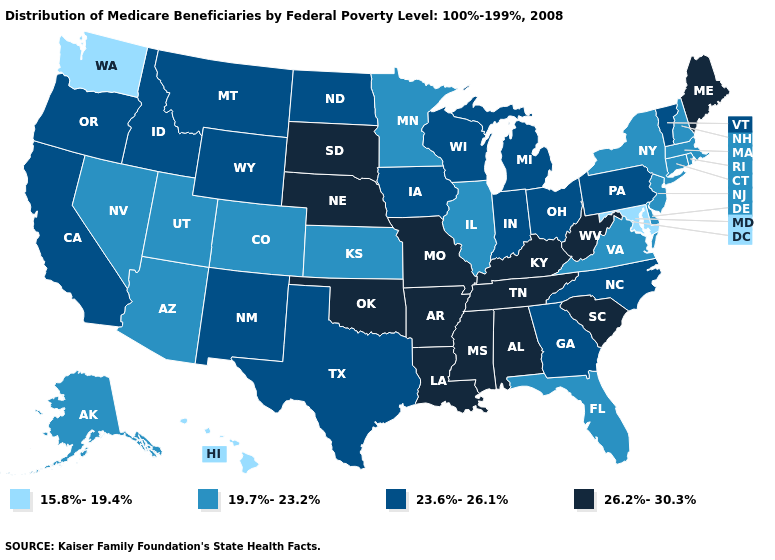Is the legend a continuous bar?
Short answer required. No. Name the states that have a value in the range 26.2%-30.3%?
Write a very short answer. Alabama, Arkansas, Kentucky, Louisiana, Maine, Mississippi, Missouri, Nebraska, Oklahoma, South Carolina, South Dakota, Tennessee, West Virginia. What is the value of Michigan?
Concise answer only. 23.6%-26.1%. Does Mississippi have a higher value than New Hampshire?
Give a very brief answer. Yes. Does Maine have the same value as Tennessee?
Be succinct. Yes. Name the states that have a value in the range 19.7%-23.2%?
Answer briefly. Alaska, Arizona, Colorado, Connecticut, Delaware, Florida, Illinois, Kansas, Massachusetts, Minnesota, Nevada, New Hampshire, New Jersey, New York, Rhode Island, Utah, Virginia. Does the first symbol in the legend represent the smallest category?
Concise answer only. Yes. What is the value of Maryland?
Keep it brief. 15.8%-19.4%. Name the states that have a value in the range 15.8%-19.4%?
Answer briefly. Hawaii, Maryland, Washington. Does Idaho have a lower value than California?
Answer briefly. No. Among the states that border Arkansas , which have the lowest value?
Short answer required. Texas. Is the legend a continuous bar?
Be succinct. No. Name the states that have a value in the range 26.2%-30.3%?
Write a very short answer. Alabama, Arkansas, Kentucky, Louisiana, Maine, Mississippi, Missouri, Nebraska, Oklahoma, South Carolina, South Dakota, Tennessee, West Virginia. What is the value of Nevada?
Quick response, please. 19.7%-23.2%. 